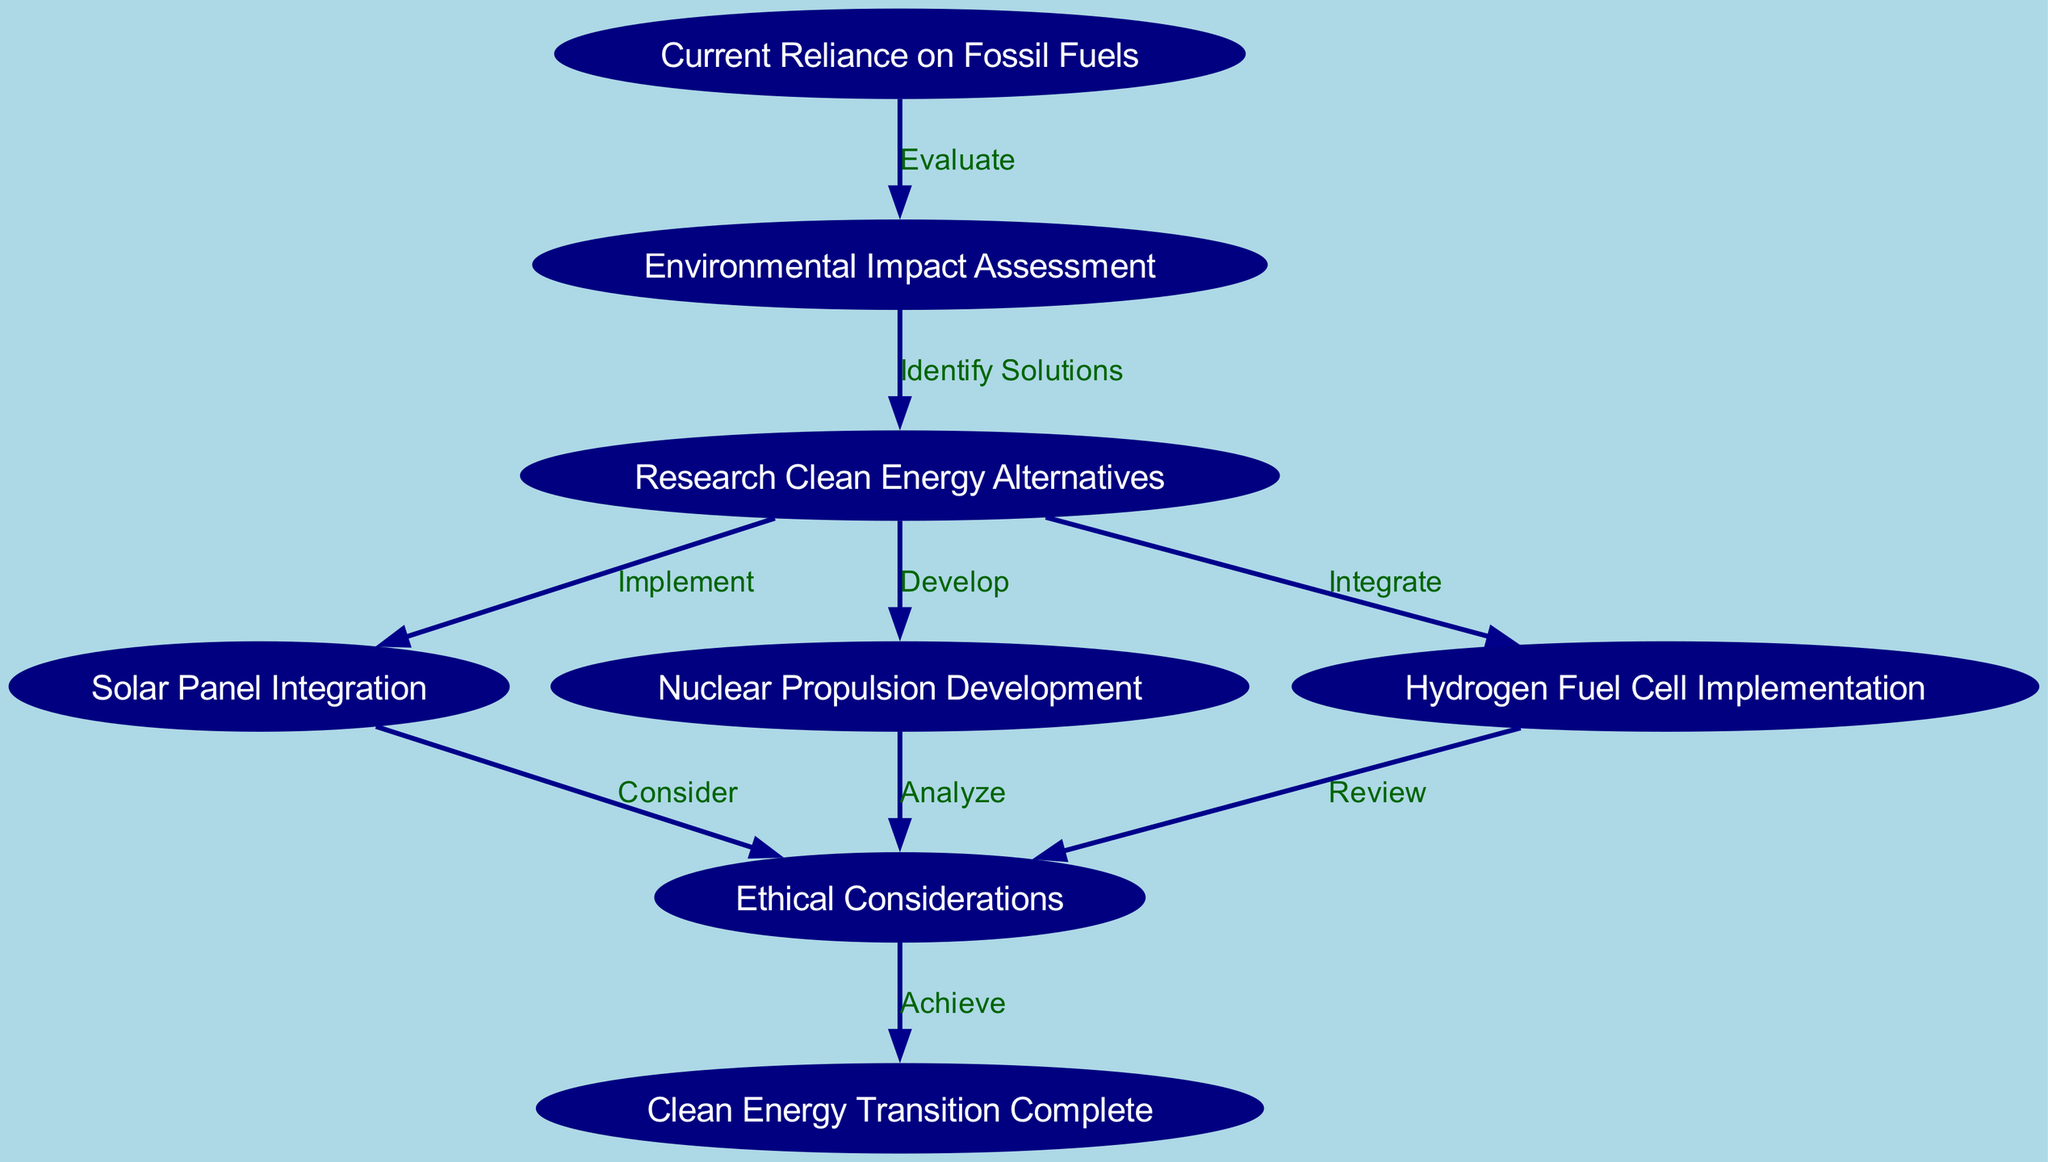What is the first node in the diagram? The first node in the diagram is "Current Reliance on Fossil Fuels," which represents the starting point of the transition process.
Answer: Current Reliance on Fossil Fuels How many edges are there in total? By counting all the connections represented in the diagram, there are a total of 9 edges that connect the nodes, illustrating the flow from one step to another.
Answer: 9 What is the last node in the transition process? The last node is "Clean Energy Transition Complete," which signifies the end goal of the process depicted in the flowchart.
Answer: Clean Energy Transition Complete Which node involves nuclear propulsion? The node that involves nuclear propulsion is "Nuclear Propulsion Development," indicating a specific focus on exploring nuclear energy as an alternative.
Answer: Nuclear Propulsion Development What action connects "Current Reliance on Fossil Fuels" to "Environmental Impact Assessment"? The action that connects these two nodes is labeled "Evaluate," which indicates the need to assess the environmental impacts of current fossil fuel usage.
Answer: Evaluate What node follows "Research Clean Energy Alternatives"? The nodes that follow "Research Clean Energy Alternatives" include "Solar Panel Integration," "Nuclear Propulsion Development," and "Hydrogen Fuel Cell Implementation," showcasing the different clean alternatives being considered.
Answer: Solar Panel Integration, Nuclear Propulsion Development, Hydrogen Fuel Cell Implementation Which nodes require ethical considerations? The node that requires ethical considerations is "Solar Panel Integration," "Nuclear Propulsion Development," and "Hydrogen Fuel Cell Implementation," as they all have implications for ethics that need to be reviewed closely.
Answer: Solar Panel Integration, Nuclear Propulsion Development, Hydrogen Fuel Cell Implementation What is the connection between "Hydrogen Fuel Cell Implementation" and "Ethical Considerations"? The connection is labeled as "Review," indicating that after integrating hydrogen fuel cells, ethical implications must be further examined.
Answer: Review What does the label "Achieve" indicate in the diagram? The label "Achieve" indicates the final step where ethical considerations are addressed leading to the completion of the clean energy transition process.
Answer: Achieve 